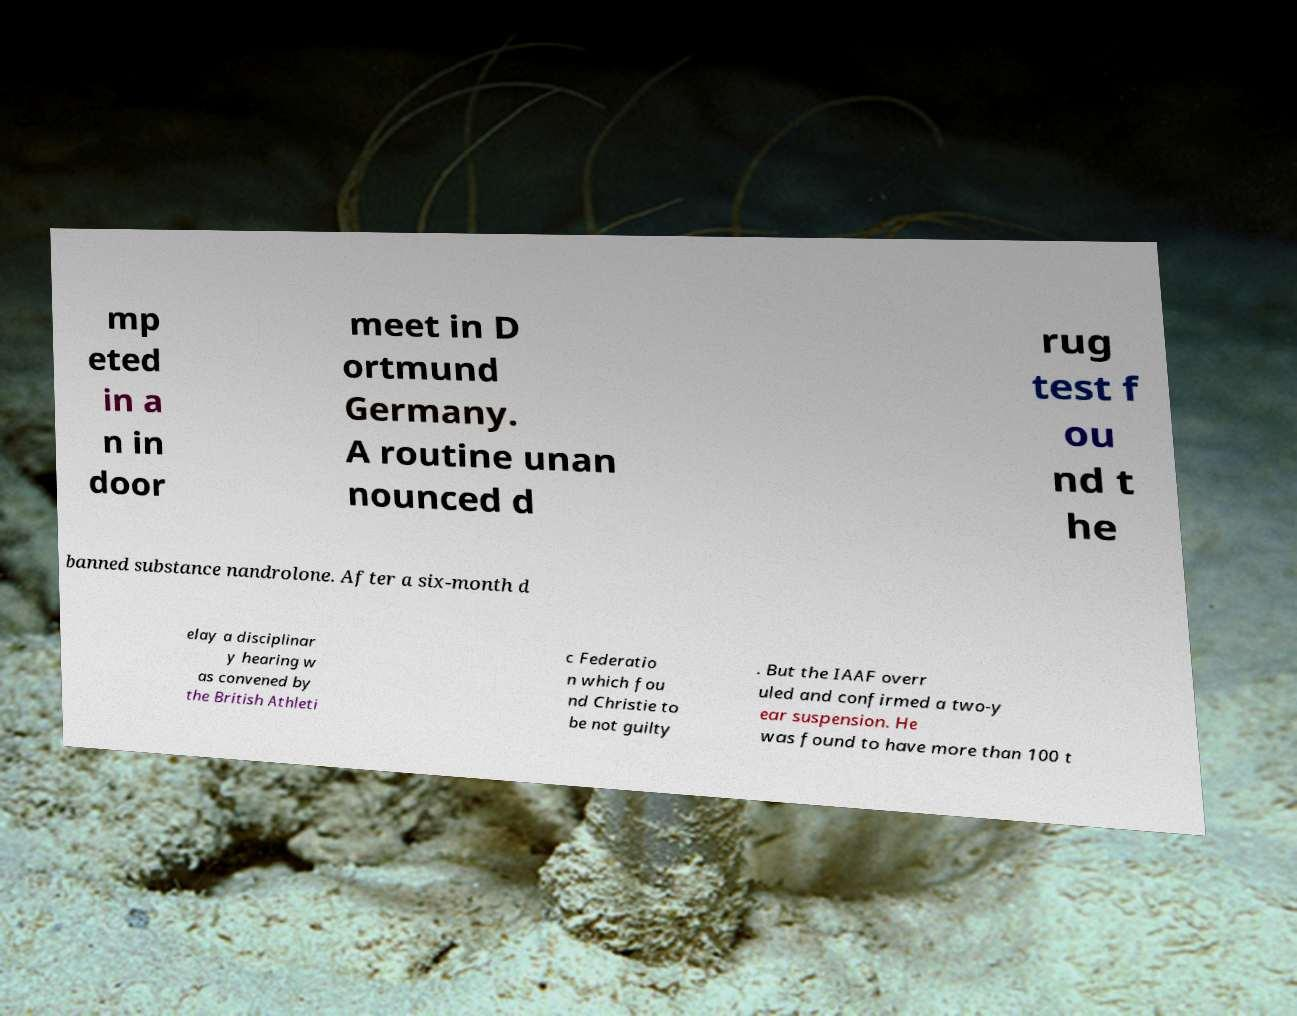What messages or text are displayed in this image? I need them in a readable, typed format. mp eted in a n in door meet in D ortmund Germany. A routine unan nounced d rug test f ou nd t he banned substance nandrolone. After a six-month d elay a disciplinar y hearing w as convened by the British Athleti c Federatio n which fou nd Christie to be not guilty . But the IAAF overr uled and confirmed a two-y ear suspension. He was found to have more than 100 t 